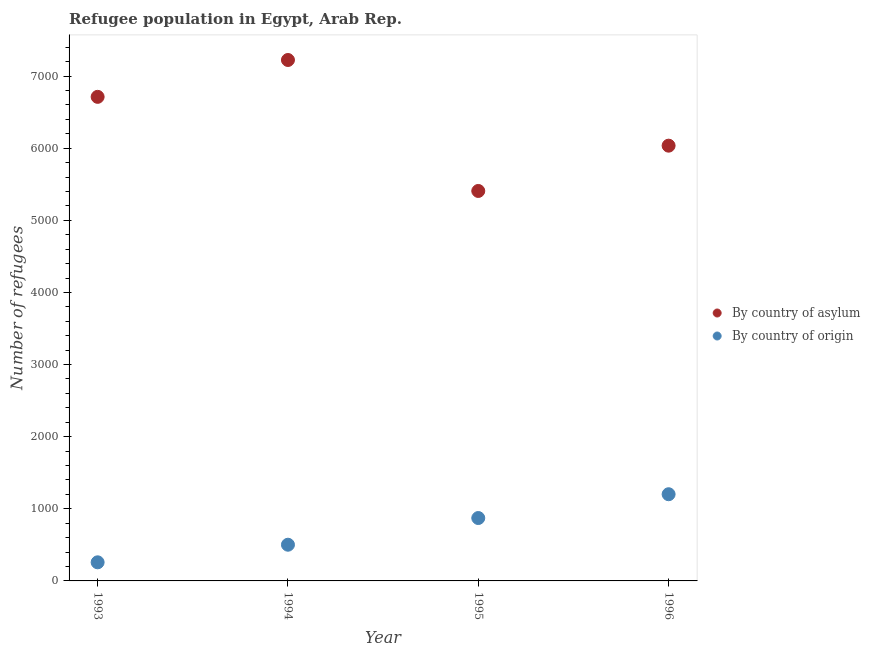What is the number of refugees by country of asylum in 1995?
Your answer should be compact. 5407. Across all years, what is the maximum number of refugees by country of asylum?
Offer a terse response. 7223. Across all years, what is the minimum number of refugees by country of asylum?
Your response must be concise. 5407. In which year was the number of refugees by country of origin maximum?
Provide a succinct answer. 1996. What is the total number of refugees by country of origin in the graph?
Offer a very short reply. 2834. What is the difference between the number of refugees by country of asylum in 1993 and that in 1995?
Give a very brief answer. 1305. What is the difference between the number of refugees by country of asylum in 1994 and the number of refugees by country of origin in 1995?
Give a very brief answer. 6351. What is the average number of refugees by country of origin per year?
Give a very brief answer. 708.5. In the year 1995, what is the difference between the number of refugees by country of asylum and number of refugees by country of origin?
Offer a very short reply. 4535. What is the ratio of the number of refugees by country of asylum in 1995 to that in 1996?
Provide a succinct answer. 0.9. Is the number of refugees by country of asylum in 1993 less than that in 1996?
Your response must be concise. No. What is the difference between the highest and the second highest number of refugees by country of origin?
Your answer should be very brief. 330. What is the difference between the highest and the lowest number of refugees by country of asylum?
Ensure brevity in your answer.  1816. In how many years, is the number of refugees by country of origin greater than the average number of refugees by country of origin taken over all years?
Provide a succinct answer. 2. Does the number of refugees by country of origin monotonically increase over the years?
Provide a succinct answer. Yes. Is the number of refugees by country of asylum strictly less than the number of refugees by country of origin over the years?
Keep it short and to the point. No. How many years are there in the graph?
Make the answer very short. 4. What is the difference between two consecutive major ticks on the Y-axis?
Provide a short and direct response. 1000. Are the values on the major ticks of Y-axis written in scientific E-notation?
Offer a very short reply. No. Does the graph contain grids?
Provide a short and direct response. No. Where does the legend appear in the graph?
Provide a short and direct response. Center right. How many legend labels are there?
Your answer should be very brief. 2. How are the legend labels stacked?
Keep it short and to the point. Vertical. What is the title of the graph?
Ensure brevity in your answer.  Refugee population in Egypt, Arab Rep. Does "Private consumption" appear as one of the legend labels in the graph?
Provide a succinct answer. No. What is the label or title of the Y-axis?
Offer a terse response. Number of refugees. What is the Number of refugees of By country of asylum in 1993?
Give a very brief answer. 6712. What is the Number of refugees of By country of origin in 1993?
Your response must be concise. 258. What is the Number of refugees of By country of asylum in 1994?
Ensure brevity in your answer.  7223. What is the Number of refugees of By country of origin in 1994?
Give a very brief answer. 502. What is the Number of refugees in By country of asylum in 1995?
Provide a succinct answer. 5407. What is the Number of refugees in By country of origin in 1995?
Provide a short and direct response. 872. What is the Number of refugees of By country of asylum in 1996?
Give a very brief answer. 6035. What is the Number of refugees of By country of origin in 1996?
Keep it short and to the point. 1202. Across all years, what is the maximum Number of refugees in By country of asylum?
Your answer should be very brief. 7223. Across all years, what is the maximum Number of refugees in By country of origin?
Make the answer very short. 1202. Across all years, what is the minimum Number of refugees in By country of asylum?
Your response must be concise. 5407. Across all years, what is the minimum Number of refugees in By country of origin?
Give a very brief answer. 258. What is the total Number of refugees in By country of asylum in the graph?
Provide a succinct answer. 2.54e+04. What is the total Number of refugees of By country of origin in the graph?
Your answer should be very brief. 2834. What is the difference between the Number of refugees in By country of asylum in 1993 and that in 1994?
Provide a succinct answer. -511. What is the difference between the Number of refugees of By country of origin in 1993 and that in 1994?
Provide a short and direct response. -244. What is the difference between the Number of refugees of By country of asylum in 1993 and that in 1995?
Provide a short and direct response. 1305. What is the difference between the Number of refugees of By country of origin in 1993 and that in 1995?
Provide a succinct answer. -614. What is the difference between the Number of refugees in By country of asylum in 1993 and that in 1996?
Make the answer very short. 677. What is the difference between the Number of refugees in By country of origin in 1993 and that in 1996?
Your response must be concise. -944. What is the difference between the Number of refugees of By country of asylum in 1994 and that in 1995?
Your response must be concise. 1816. What is the difference between the Number of refugees of By country of origin in 1994 and that in 1995?
Offer a terse response. -370. What is the difference between the Number of refugees of By country of asylum in 1994 and that in 1996?
Give a very brief answer. 1188. What is the difference between the Number of refugees of By country of origin in 1994 and that in 1996?
Ensure brevity in your answer.  -700. What is the difference between the Number of refugees of By country of asylum in 1995 and that in 1996?
Provide a succinct answer. -628. What is the difference between the Number of refugees in By country of origin in 1995 and that in 1996?
Ensure brevity in your answer.  -330. What is the difference between the Number of refugees of By country of asylum in 1993 and the Number of refugees of By country of origin in 1994?
Your answer should be very brief. 6210. What is the difference between the Number of refugees in By country of asylum in 1993 and the Number of refugees in By country of origin in 1995?
Provide a short and direct response. 5840. What is the difference between the Number of refugees of By country of asylum in 1993 and the Number of refugees of By country of origin in 1996?
Your answer should be compact. 5510. What is the difference between the Number of refugees of By country of asylum in 1994 and the Number of refugees of By country of origin in 1995?
Offer a very short reply. 6351. What is the difference between the Number of refugees of By country of asylum in 1994 and the Number of refugees of By country of origin in 1996?
Keep it short and to the point. 6021. What is the difference between the Number of refugees in By country of asylum in 1995 and the Number of refugees in By country of origin in 1996?
Offer a terse response. 4205. What is the average Number of refugees in By country of asylum per year?
Give a very brief answer. 6344.25. What is the average Number of refugees of By country of origin per year?
Your answer should be compact. 708.5. In the year 1993, what is the difference between the Number of refugees of By country of asylum and Number of refugees of By country of origin?
Your answer should be very brief. 6454. In the year 1994, what is the difference between the Number of refugees of By country of asylum and Number of refugees of By country of origin?
Offer a terse response. 6721. In the year 1995, what is the difference between the Number of refugees in By country of asylum and Number of refugees in By country of origin?
Ensure brevity in your answer.  4535. In the year 1996, what is the difference between the Number of refugees of By country of asylum and Number of refugees of By country of origin?
Keep it short and to the point. 4833. What is the ratio of the Number of refugees of By country of asylum in 1993 to that in 1994?
Make the answer very short. 0.93. What is the ratio of the Number of refugees in By country of origin in 1993 to that in 1994?
Provide a succinct answer. 0.51. What is the ratio of the Number of refugees of By country of asylum in 1993 to that in 1995?
Your response must be concise. 1.24. What is the ratio of the Number of refugees of By country of origin in 1993 to that in 1995?
Your answer should be compact. 0.3. What is the ratio of the Number of refugees in By country of asylum in 1993 to that in 1996?
Provide a succinct answer. 1.11. What is the ratio of the Number of refugees of By country of origin in 1993 to that in 1996?
Give a very brief answer. 0.21. What is the ratio of the Number of refugees in By country of asylum in 1994 to that in 1995?
Your answer should be compact. 1.34. What is the ratio of the Number of refugees in By country of origin in 1994 to that in 1995?
Provide a short and direct response. 0.58. What is the ratio of the Number of refugees in By country of asylum in 1994 to that in 1996?
Provide a succinct answer. 1.2. What is the ratio of the Number of refugees of By country of origin in 1994 to that in 1996?
Your answer should be compact. 0.42. What is the ratio of the Number of refugees in By country of asylum in 1995 to that in 1996?
Keep it short and to the point. 0.9. What is the ratio of the Number of refugees in By country of origin in 1995 to that in 1996?
Ensure brevity in your answer.  0.73. What is the difference between the highest and the second highest Number of refugees of By country of asylum?
Offer a very short reply. 511. What is the difference between the highest and the second highest Number of refugees of By country of origin?
Your answer should be compact. 330. What is the difference between the highest and the lowest Number of refugees in By country of asylum?
Offer a very short reply. 1816. What is the difference between the highest and the lowest Number of refugees of By country of origin?
Provide a succinct answer. 944. 